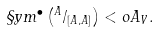Convert formula to latex. <formula><loc_0><loc_0><loc_500><loc_500>\S y m ^ { \bullet } \left ( ^ { A } / _ { [ A , A ] } \right ) < o A _ { V } .</formula> 